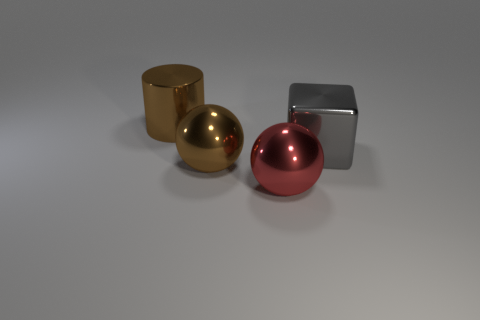Add 1 brown metallic cylinders. How many objects exist? 5 Subtract all cylinders. How many objects are left? 3 Subtract 1 cylinders. How many cylinders are left? 0 Subtract all brown spheres. How many spheres are left? 1 Subtract all cyan rubber spheres. Subtract all large metallic cylinders. How many objects are left? 3 Add 4 big brown cylinders. How many big brown cylinders are left? 5 Add 2 brown shiny cylinders. How many brown shiny cylinders exist? 3 Subtract 0 purple cylinders. How many objects are left? 4 Subtract all green balls. Subtract all gray cubes. How many balls are left? 2 Subtract all cyan cubes. How many green spheres are left? 0 